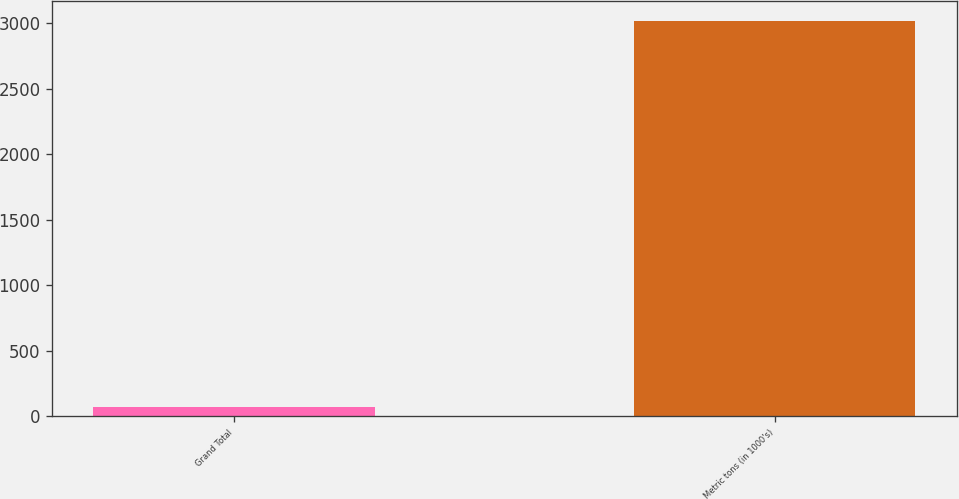Convert chart to OTSL. <chart><loc_0><loc_0><loc_500><loc_500><bar_chart><fcel>Grand Total<fcel>Metric tons (in 1000's)<nl><fcel>70<fcel>3016<nl></chart> 